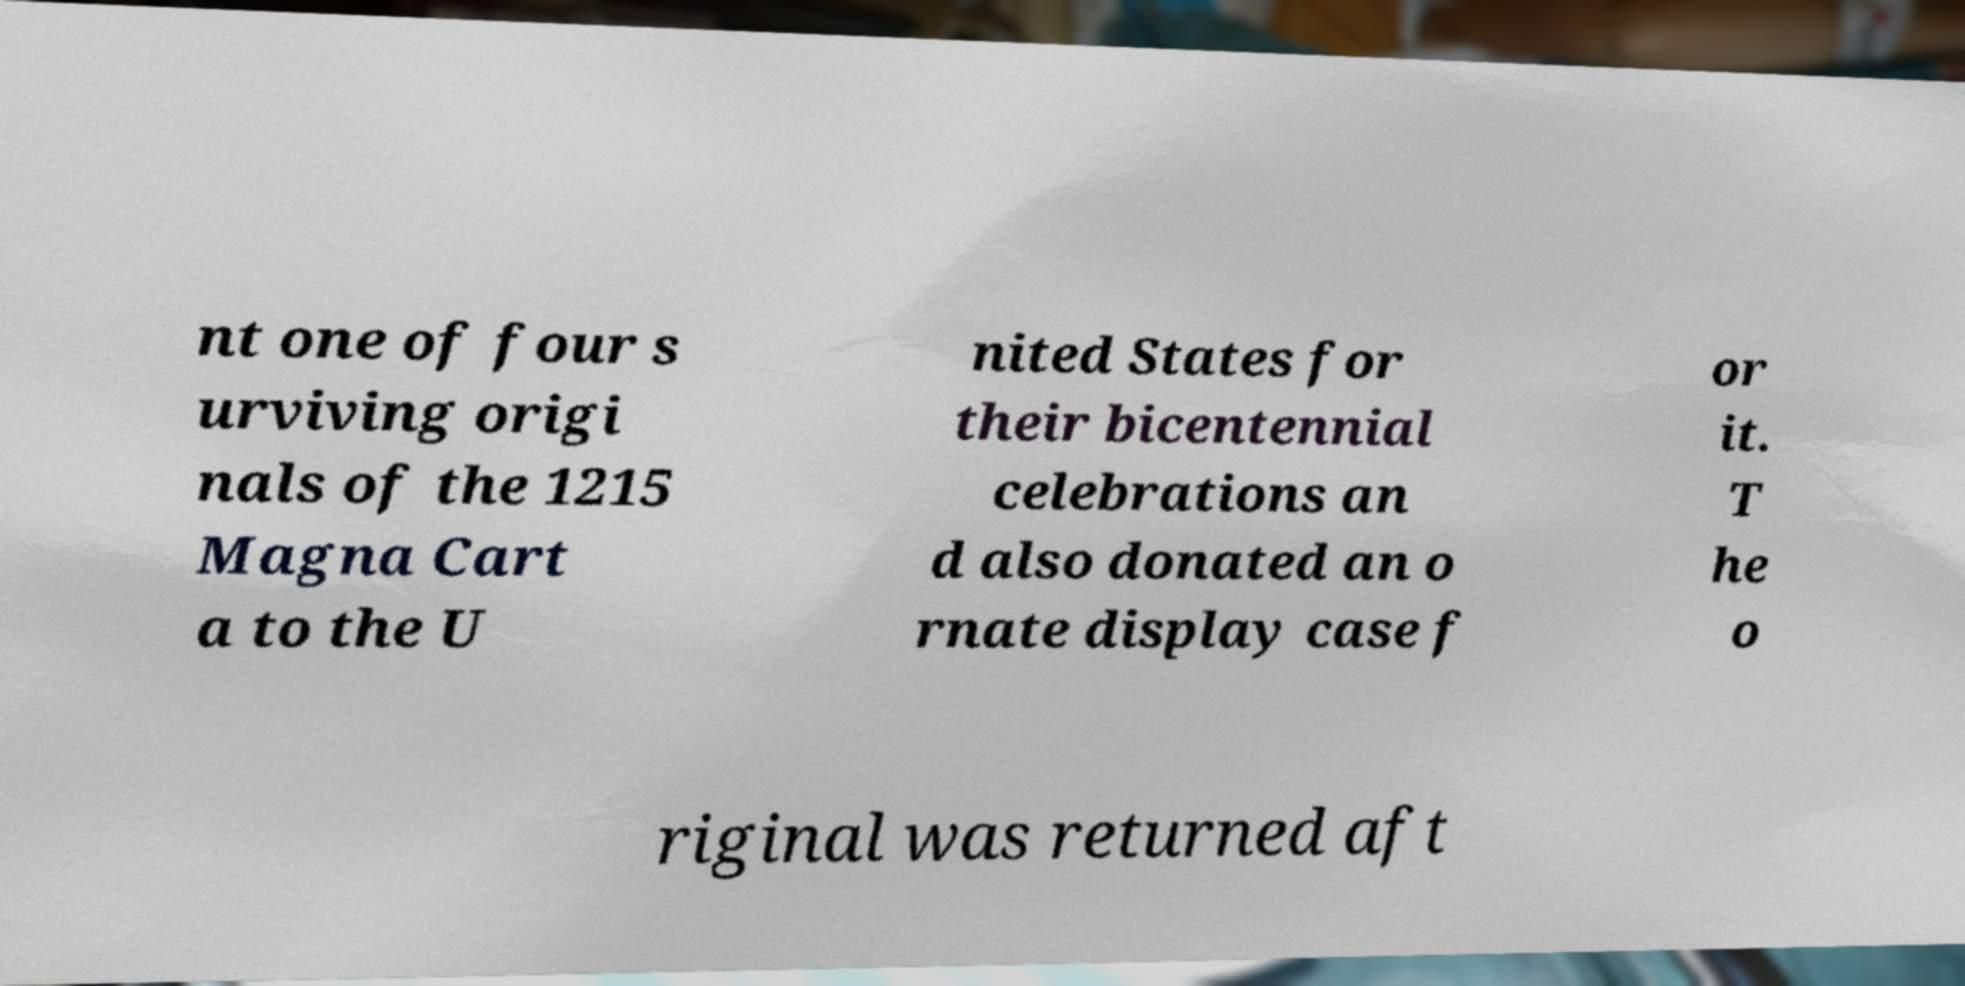There's text embedded in this image that I need extracted. Can you transcribe it verbatim? nt one of four s urviving origi nals of the 1215 Magna Cart a to the U nited States for their bicentennial celebrations an d also donated an o rnate display case f or it. T he o riginal was returned aft 